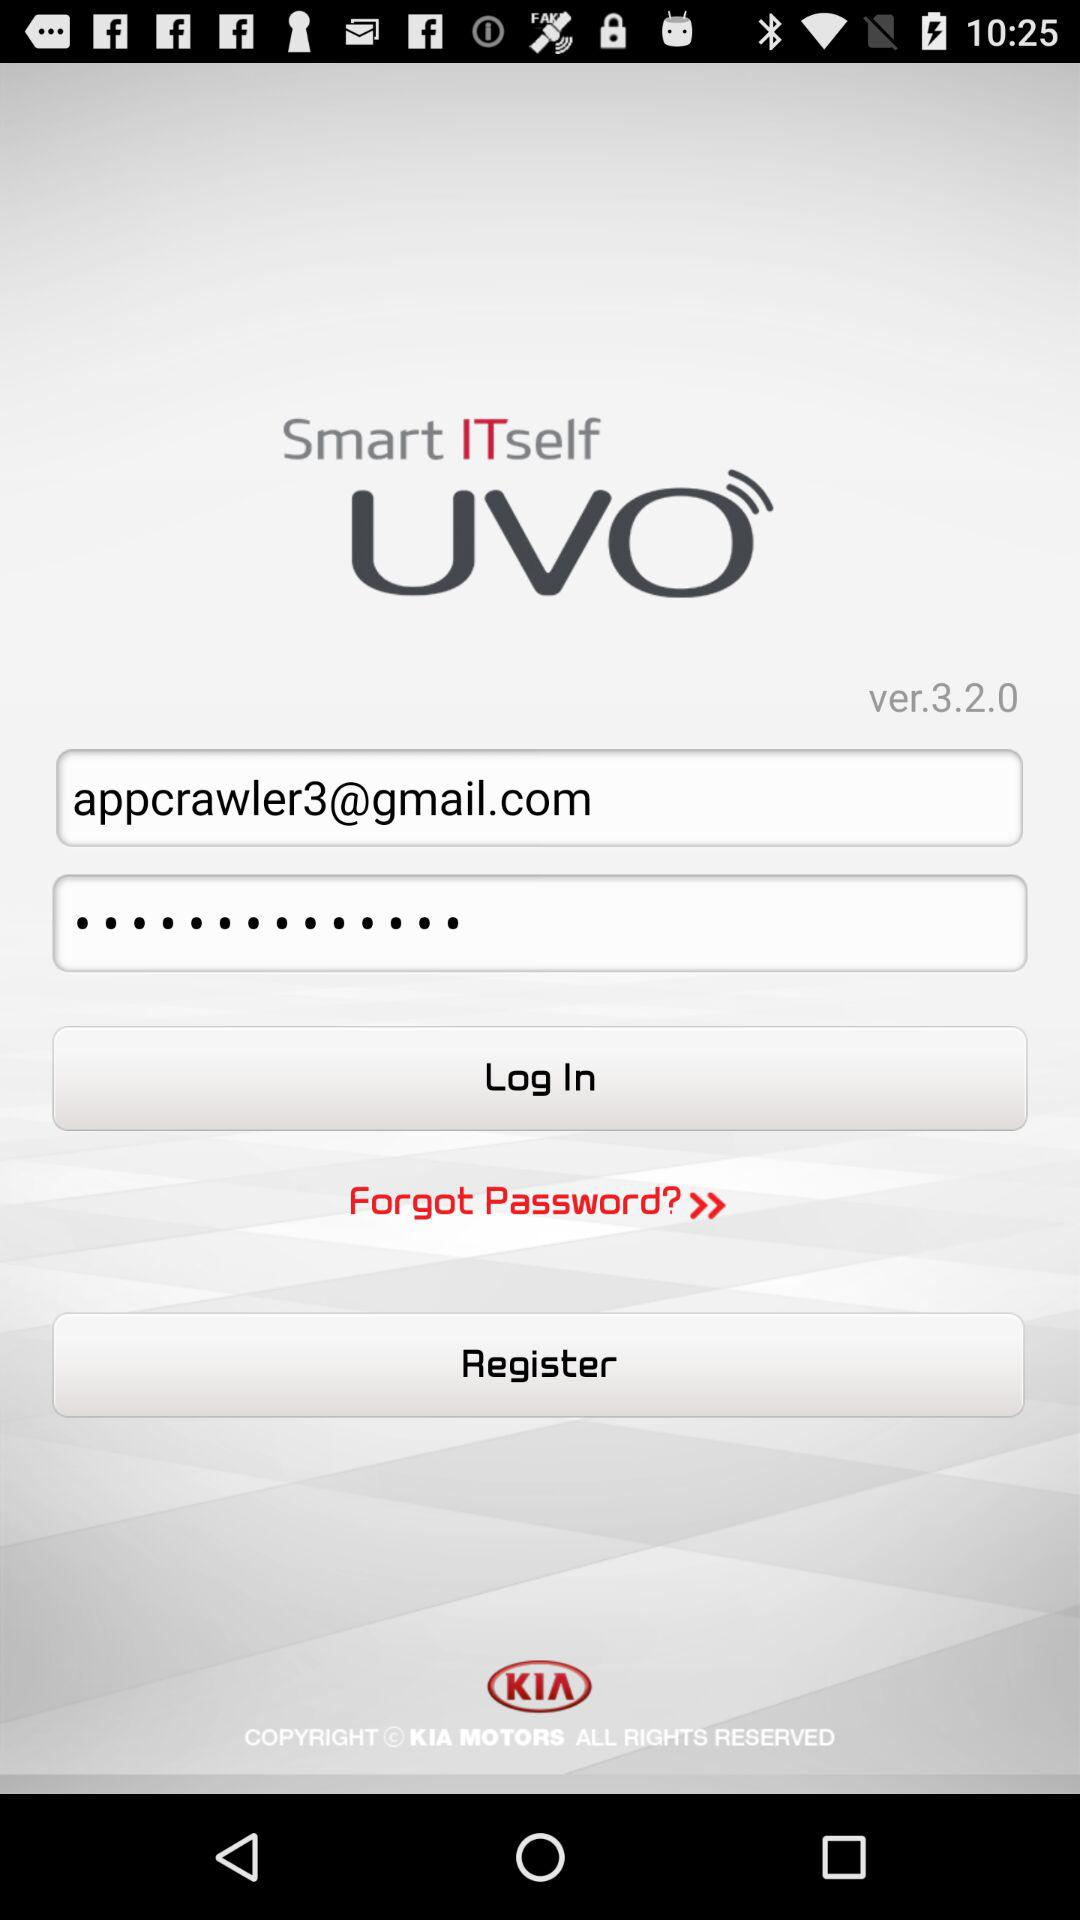What is the email address? The email address is appcrawler3@gmail.com. 